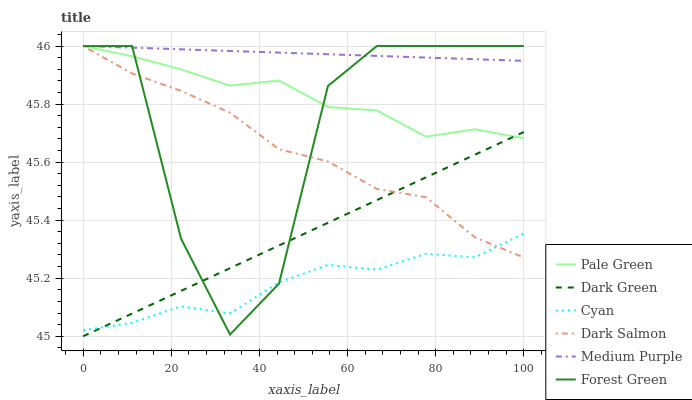Does Cyan have the minimum area under the curve?
Answer yes or no. Yes. Does Medium Purple have the maximum area under the curve?
Answer yes or no. Yes. Does Forest Green have the minimum area under the curve?
Answer yes or no. No. Does Forest Green have the maximum area under the curve?
Answer yes or no. No. Is Medium Purple the smoothest?
Answer yes or no. Yes. Is Forest Green the roughest?
Answer yes or no. Yes. Is Forest Green the smoothest?
Answer yes or no. No. Is Medium Purple the roughest?
Answer yes or no. No. Does Dark Green have the lowest value?
Answer yes or no. Yes. Does Forest Green have the lowest value?
Answer yes or no. No. Does Pale Green have the highest value?
Answer yes or no. Yes. Does Cyan have the highest value?
Answer yes or no. No. Is Cyan less than Pale Green?
Answer yes or no. Yes. Is Pale Green greater than Cyan?
Answer yes or no. Yes. Does Dark Green intersect Dark Salmon?
Answer yes or no. Yes. Is Dark Green less than Dark Salmon?
Answer yes or no. No. Is Dark Green greater than Dark Salmon?
Answer yes or no. No. Does Cyan intersect Pale Green?
Answer yes or no. No. 